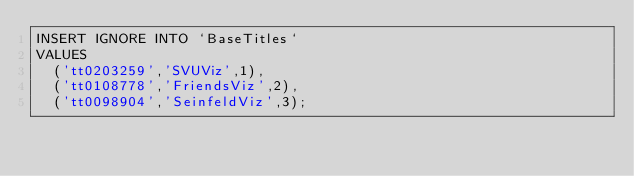Convert code to text. <code><loc_0><loc_0><loc_500><loc_500><_SQL_>INSERT IGNORE INTO `BaseTitles` 
VALUES
  ('tt0203259','SVUViz',1),
  ('tt0108778','FriendsViz',2),
  ('tt0098904','SeinfeldViz',3);

</code> 